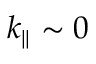<formula> <loc_0><loc_0><loc_500><loc_500>k _ { | | } \sim 0</formula> 